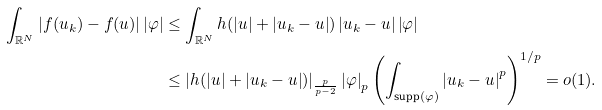<formula> <loc_0><loc_0><loc_500><loc_500>\int _ { \mathbb { R } ^ { N } } \left | f ( u _ { k } ) - f ( u ) \right | \left | \varphi \right | & \leq \int _ { \mathbb { R } ^ { N } } h ( \left | u \right | + \left | u _ { k } - u \right | ) \left | u _ { k } - u \right | \left | \varphi \right | \\ & \leq \left | h ( \left | u \right | + \left | u _ { k } - u \right | ) \right | _ { \frac { p } { p - 2 } } \left | \varphi \right | _ { p } \left ( \int _ { \text {supp} ( \varphi ) } \left | u _ { k } - u \right | ^ { p } \right ) ^ { 1 / p } = o ( 1 ) .</formula> 